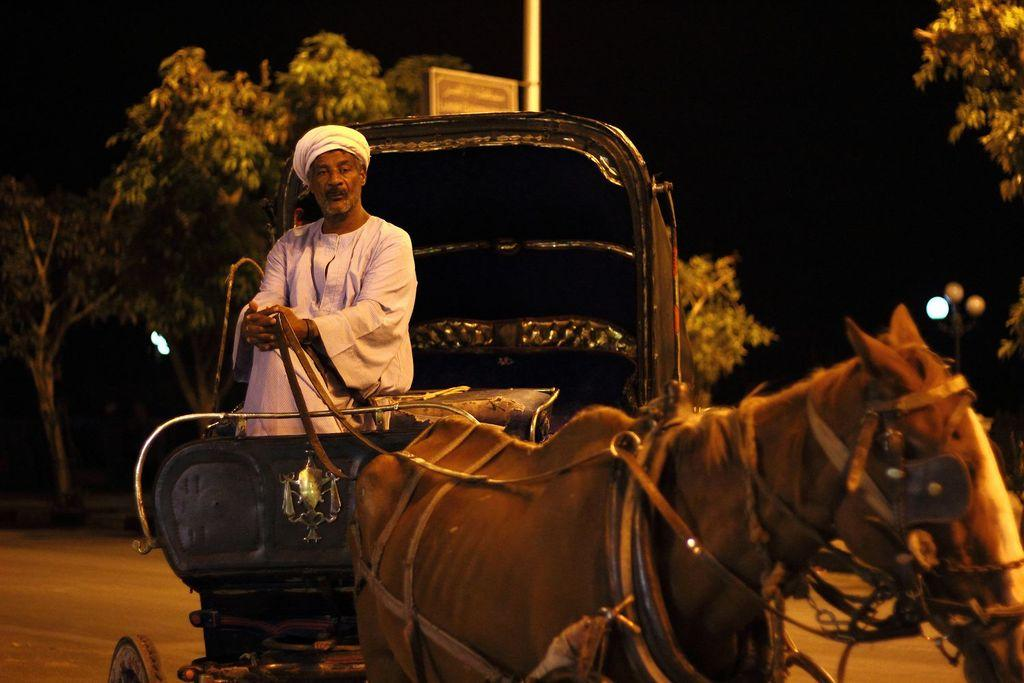What animal is present in the image? There is a horse in the image. What is attached to the horse? There is a cart in the image. Who is riding the horse? A man is riding the horse. What is the man wearing? The man is wearing a white-colored dress. What can be seen behind the man? There is a tree behind the man. What time of day is depicted in the image? It is night time in the image. What type of beef can be seen being prepared in the image? There is no beef present in the image; it features a horse, a cart, a man, and a tree. Where is the kitten in the image? There is no kitten present in the image. 